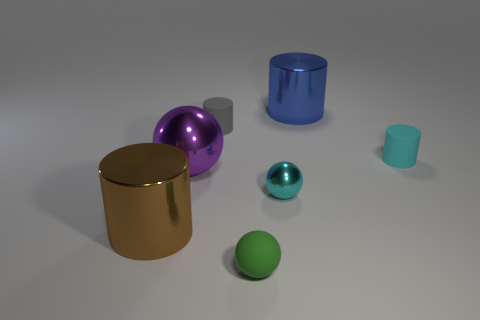Subtract all metal balls. How many balls are left? 1 Add 2 brown shiny things. How many objects exist? 9 Subtract all cylinders. How many objects are left? 3 Add 2 green things. How many green things exist? 3 Subtract all gray cylinders. How many cylinders are left? 3 Subtract 1 gray cylinders. How many objects are left? 6 Subtract 2 spheres. How many spheres are left? 1 Subtract all yellow balls. Subtract all yellow blocks. How many balls are left? 3 Subtract all green cylinders. How many yellow balls are left? 0 Subtract all green things. Subtract all small cyan rubber cylinders. How many objects are left? 5 